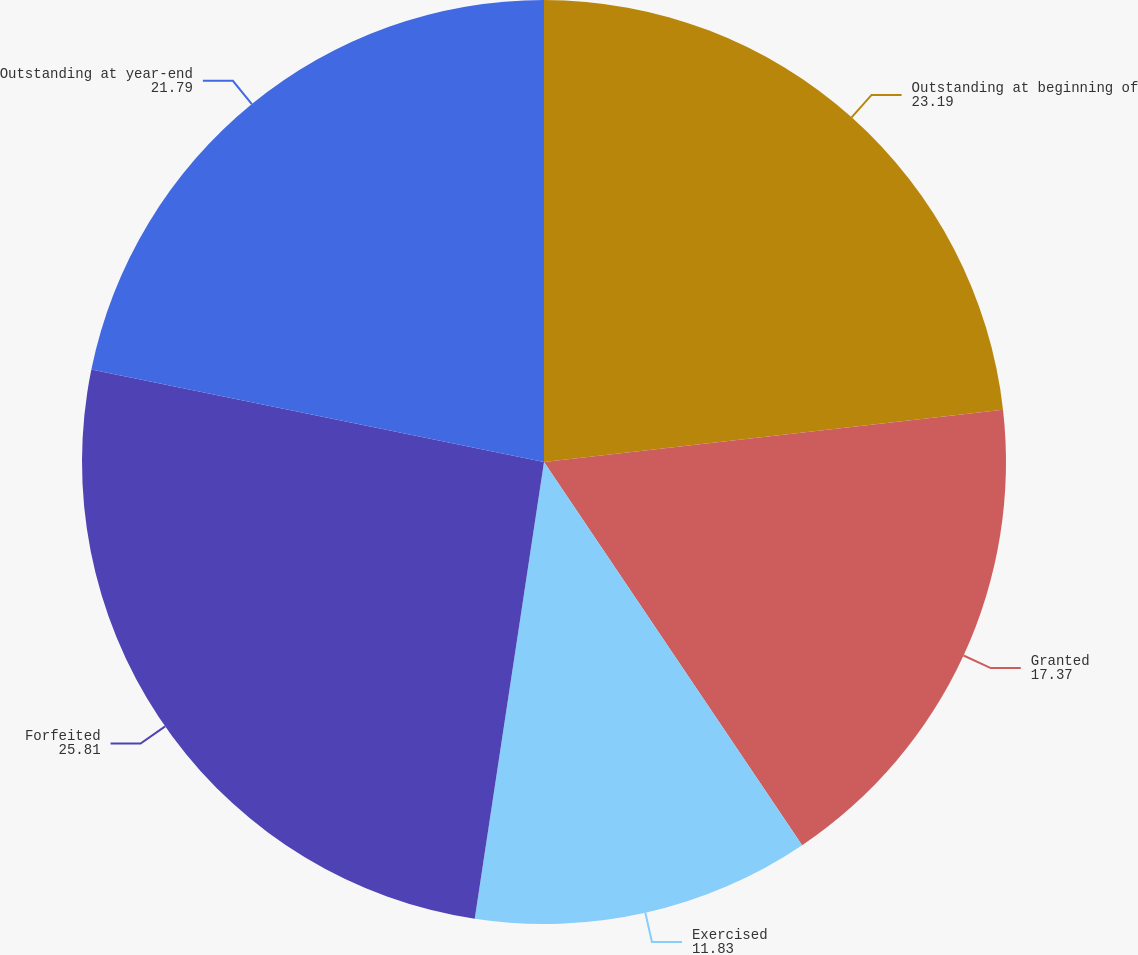Convert chart. <chart><loc_0><loc_0><loc_500><loc_500><pie_chart><fcel>Outstanding at beginning of<fcel>Granted<fcel>Exercised<fcel>Forfeited<fcel>Outstanding at year-end<nl><fcel>23.19%<fcel>17.37%<fcel>11.83%<fcel>25.81%<fcel>21.79%<nl></chart> 